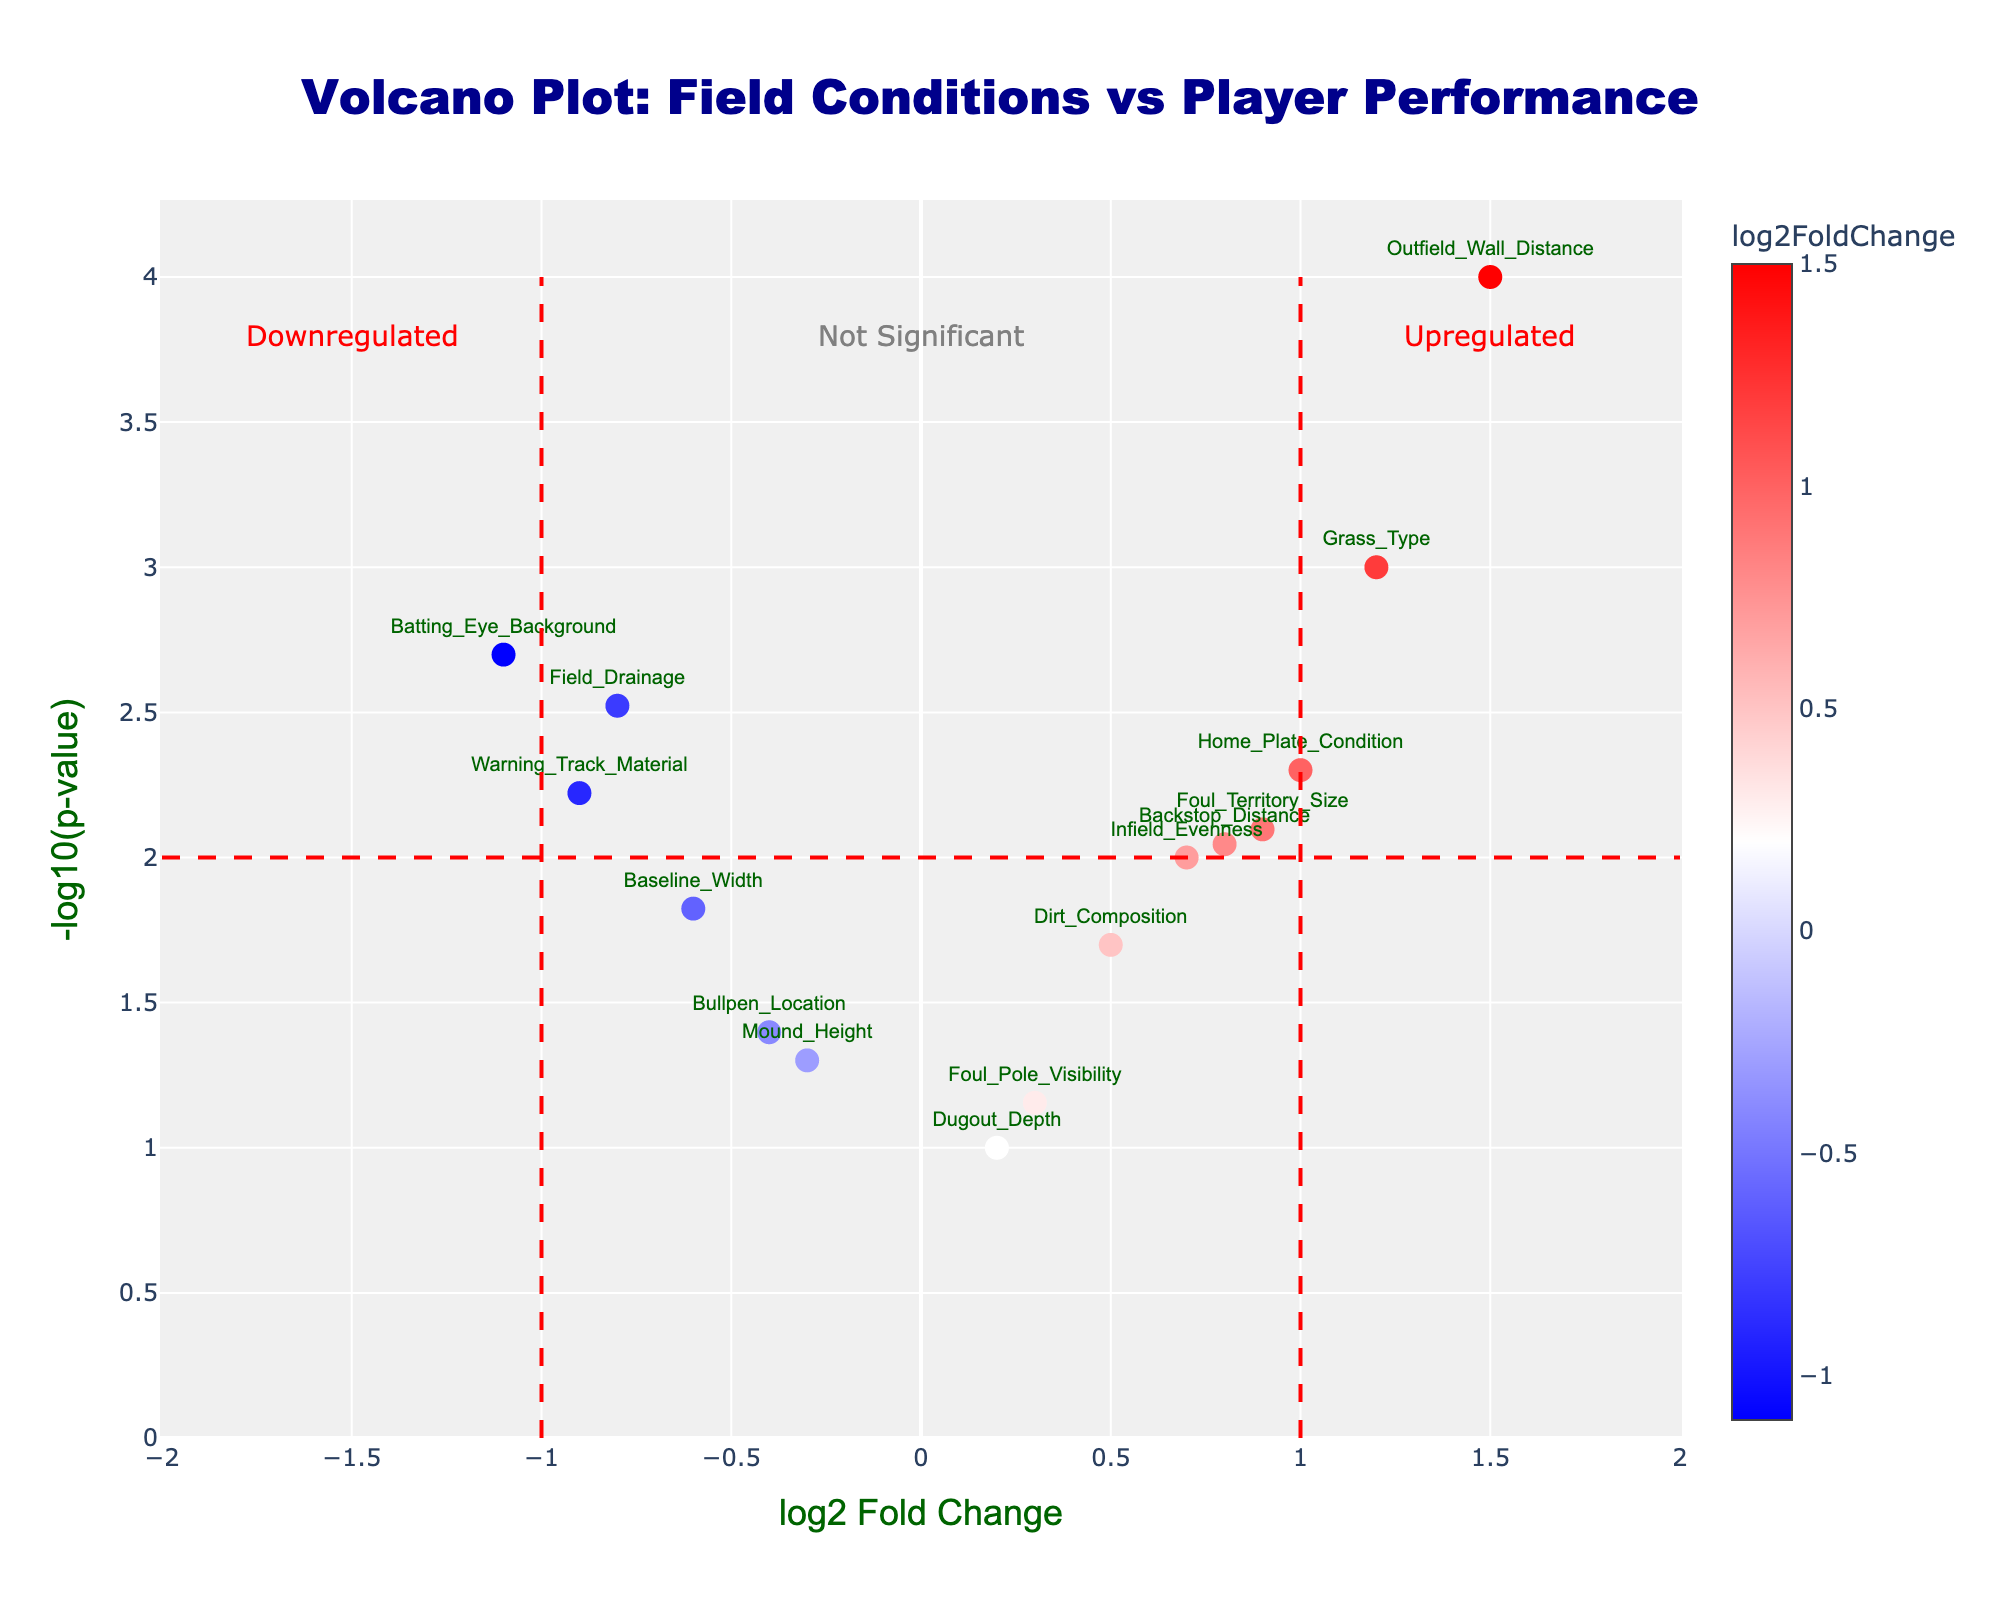What is the title of the volcano plot? The title of the volcano plot can be found at the top center of the figure. It is usually bolded and larger in size compared to other text elements. The title is "Volcano Plot: Field Conditions vs Player Performance" as it is clearly labeled at the top.
Answer: Volcano Plot: Field Conditions vs Player Performance What are the labels on the two axes? Axis labels are usually found next to or along the respective axes, with the x-axis label at the bottom and the y-axis label along the side. For this figure, the x-axis is labeled "log2 Fold Change" and the y-axis is labeled "-log10(p-value)".
Answer: log2 Fold Change, -log10(p-value) How many data points are there in the plot? By counting the markers (points) present in the plot, you can determine the number of data points. Each marker represents a specific field condition affecting player performance. There are several points, each annotated with the name of the field condition. In total, there are 14 points representing different conditions.
Answer: 14 Which field condition has the highest -log10(p-value) and what is its value? To find the highest -log10(p-value) value, look at the highest point on the y-axis, as -log10(p-value) is plotted on the y-axis. The gene at this highest point is "Outfield_Wall_Distance", and its value is closely around 4.
Answer: Outfield_Wall_Distance, approximately 4 What field condition has the most extreme log2FoldChange in either direction? To identify the field condition with the most extreme log2FoldChange, locate the points farthest to the left and right along the x-axis. The field condition with the largest positive log2FoldChange is "Outfield_Wall_Distance" with a value of 1.5, and the one with the largest negative log2FoldChange is "Batting_Eye_Background" with a value of -1.1.
Answer: Outfield_Wall_Distance and Batting_Eye_Background What does the color of the markers indicate in the plot? The color of each marker typically represents the value of the log2FoldChange, where a custom color scale is used. As per the figure description, blue shades represent negative values, white represents values close to zero, and red shades represent positive values, shown by the color gradient along the x-axis.
Answer: log2FoldChange value Which field conditions are not significantly affecting player performance? Field conditions that are not significantly affecting player performance are those whose markers fall below the horizontal threshold line at y = 2. They include "Mound_Height", "Dugout_Depth", "Bullpen_Location", and "Foul_Pole_Visibility".
Answer: Mound_Height, Dugout_Depth, Bullpen_Location, Foul_Pole_Visibility Among the significant conditions, which has the smallest fold change but is still significant? Significant conditions are those above the y-threshold of 2. The one with the smallest absolute log2FoldChange but still significant is "Field_Drainage" with a -0.8 fold change.
Answer: Field_Drainage 